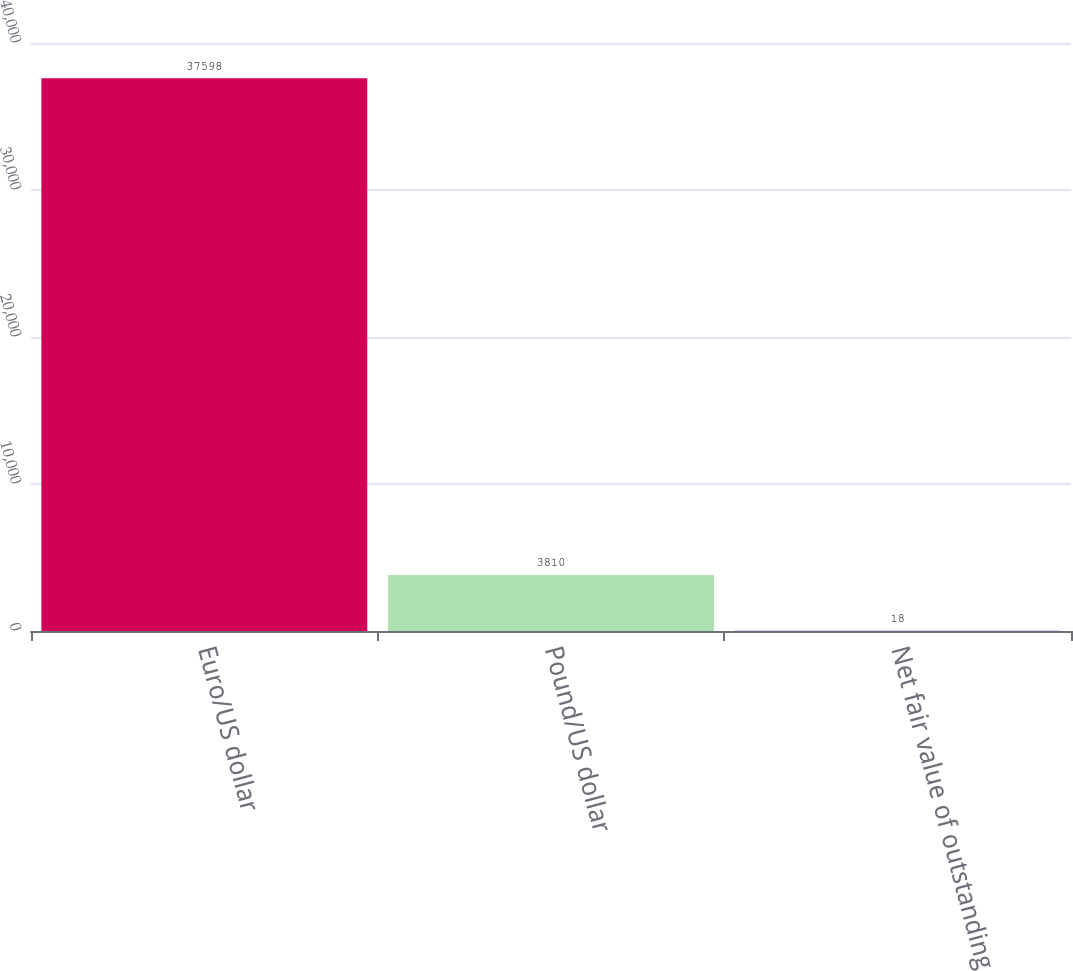Convert chart to OTSL. <chart><loc_0><loc_0><loc_500><loc_500><bar_chart><fcel>Euro/US dollar<fcel>Pound/US dollar<fcel>Net fair value of outstanding<nl><fcel>37598<fcel>3810<fcel>18<nl></chart> 